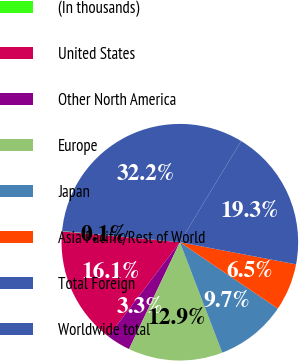<chart> <loc_0><loc_0><loc_500><loc_500><pie_chart><fcel>(In thousands)<fcel>United States<fcel>Other North America<fcel>Europe<fcel>Japan<fcel>Asia Pacific/Rest of World<fcel>Total Foreign<fcel>Worldwide total<nl><fcel>0.06%<fcel>16.11%<fcel>3.27%<fcel>12.9%<fcel>9.69%<fcel>6.48%<fcel>19.32%<fcel>32.16%<nl></chart> 